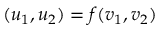<formula> <loc_0><loc_0><loc_500><loc_500>( u _ { 1 } , u _ { 2 } ) = f ( v _ { 1 } , v _ { 2 } )</formula> 